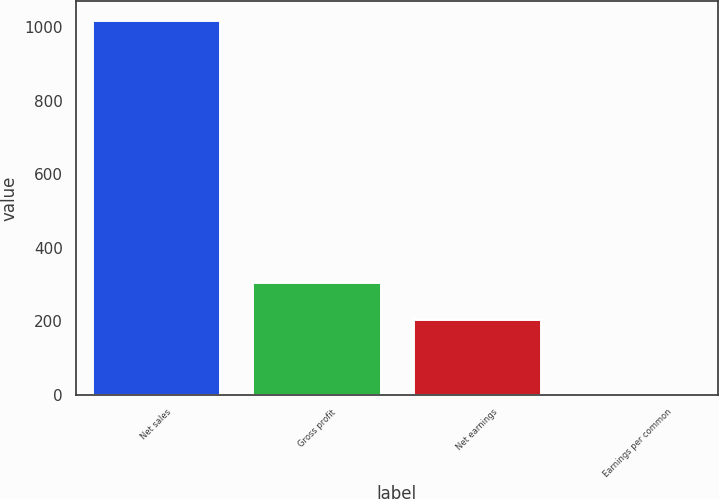Convert chart. <chart><loc_0><loc_0><loc_500><loc_500><bar_chart><fcel>Net sales<fcel>Gross profit<fcel>Net earnings<fcel>Earnings per common<nl><fcel>1020<fcel>306.45<fcel>204.52<fcel>0.66<nl></chart> 